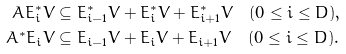<formula> <loc_0><loc_0><loc_500><loc_500>A E ^ { * } _ { i } V & \subseteq E ^ { * } _ { i - 1 } V + E ^ { * } _ { i } V + E ^ { * } _ { i + 1 } V \quad ( 0 \leq i \leq D ) , \\ A ^ { * } E _ { i } V & \subseteq E _ { i - 1 } V + E _ { i } V + E _ { i + 1 } V \quad ( 0 \leq i \leq D ) .</formula> 